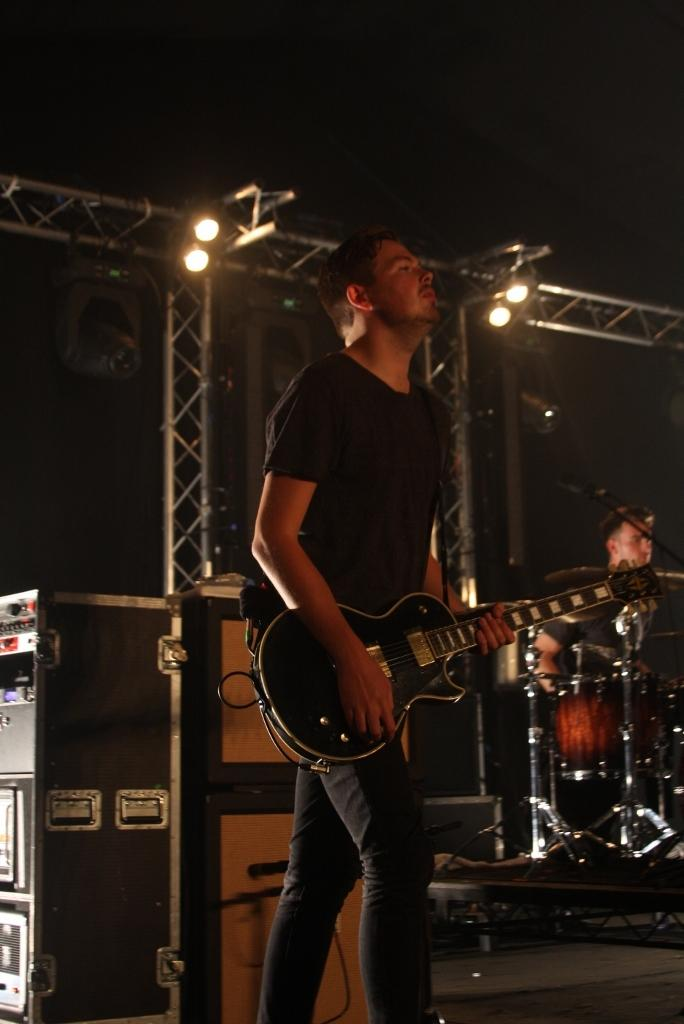What is the main subject of the image? There is a person in the center of the image. What is the person doing in the image? The person is playing a guitar. What else can be seen in the image besides the person playing the guitar? There are musical instruments in the background, and at least one other person is present in the background. What is visible at the top of the image? Lights are visible at the top of the image. How many ducks are visible in the image? There are no ducks present in the image. What type of feather can be seen on the person playing the guitar? There is no feather visible on the person playing the guitar in the image. 